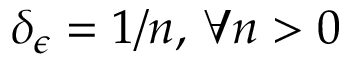<formula> <loc_0><loc_0><loc_500><loc_500>\delta _ { \epsilon } = 1 / n , \, \forall n > 0</formula> 